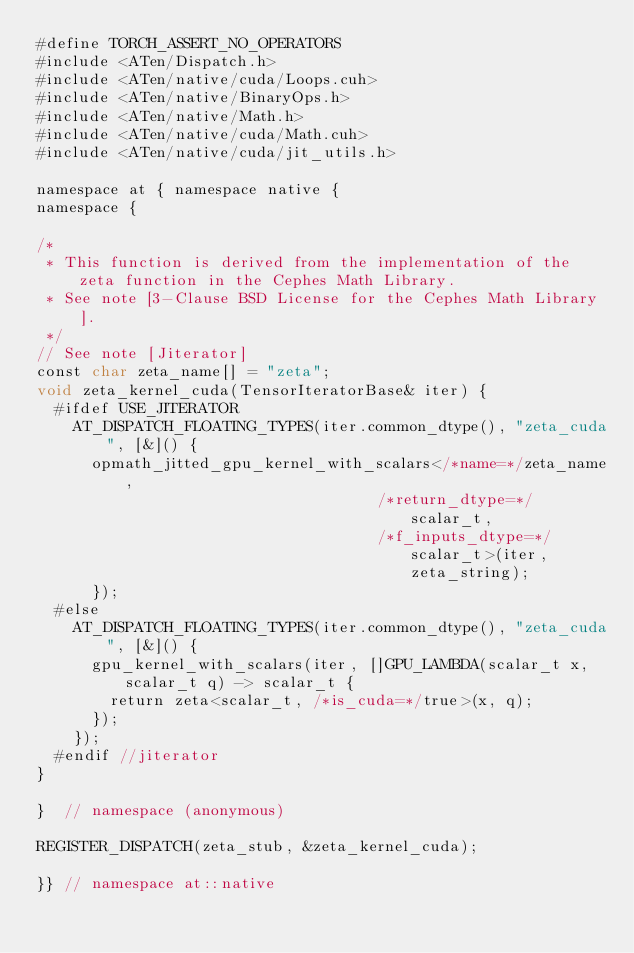Convert code to text. <code><loc_0><loc_0><loc_500><loc_500><_Cuda_>#define TORCH_ASSERT_NO_OPERATORS
#include <ATen/Dispatch.h>
#include <ATen/native/cuda/Loops.cuh>
#include <ATen/native/BinaryOps.h>
#include <ATen/native/Math.h>
#include <ATen/native/cuda/Math.cuh>
#include <ATen/native/cuda/jit_utils.h>

namespace at { namespace native {
namespace {

/*
 * This function is derived from the implementation of the zeta function in the Cephes Math Library.
 * See note [3-Clause BSD License for the Cephes Math Library].
 */
// See note [Jiterator]
const char zeta_name[] = "zeta";
void zeta_kernel_cuda(TensorIteratorBase& iter) {
  #ifdef USE_JITERATOR
    AT_DISPATCH_FLOATING_TYPES(iter.common_dtype(), "zeta_cuda", [&]() {
      opmath_jitted_gpu_kernel_with_scalars</*name=*/zeta_name,
                                     /*return_dtype=*/ scalar_t,
                                     /*f_inputs_dtype=*/ scalar_t>(iter, zeta_string);
      });
  #else
    AT_DISPATCH_FLOATING_TYPES(iter.common_dtype(), "zeta_cuda", [&]() {
      gpu_kernel_with_scalars(iter, []GPU_LAMBDA(scalar_t x, scalar_t q) -> scalar_t {
        return zeta<scalar_t, /*is_cuda=*/true>(x, q);
      });
    });
  #endif //jiterator
}

}  // namespace (anonymous)

REGISTER_DISPATCH(zeta_stub, &zeta_kernel_cuda);

}} // namespace at::native
</code> 